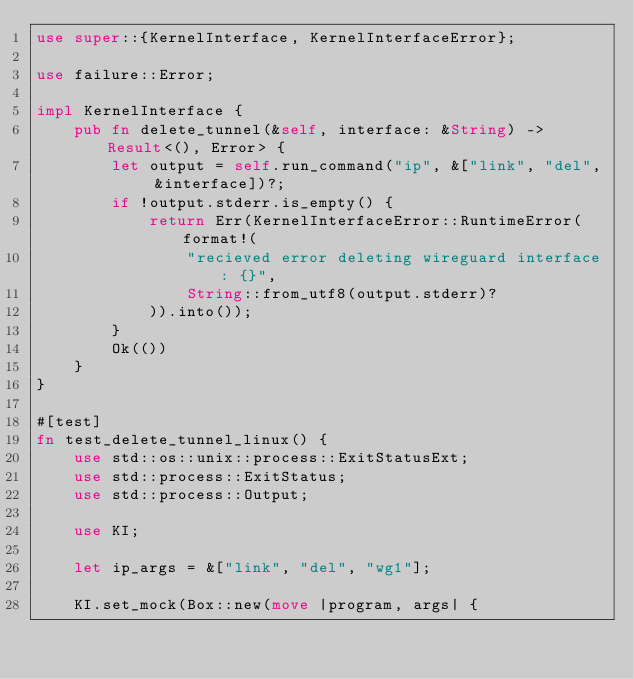Convert code to text. <code><loc_0><loc_0><loc_500><loc_500><_Rust_>use super::{KernelInterface, KernelInterfaceError};

use failure::Error;

impl KernelInterface {
    pub fn delete_tunnel(&self, interface: &String) -> Result<(), Error> {
        let output = self.run_command("ip", &["link", "del", &interface])?;
        if !output.stderr.is_empty() {
            return Err(KernelInterfaceError::RuntimeError(format!(
                "recieved error deleting wireguard interface: {}",
                String::from_utf8(output.stderr)?
            )).into());
        }
        Ok(())
    }
}

#[test]
fn test_delete_tunnel_linux() {
    use std::os::unix::process::ExitStatusExt;
    use std::process::ExitStatus;
    use std::process::Output;

    use KI;

    let ip_args = &["link", "del", "wg1"];

    KI.set_mock(Box::new(move |program, args| {</code> 